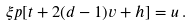<formula> <loc_0><loc_0><loc_500><loc_500>\xi p [ t + 2 ( d - 1 ) v + h ] = u \, .</formula> 